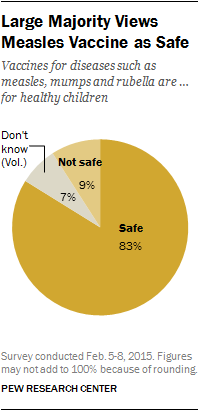Give some essential details in this illustration. The difference in the value of the smallest two segments of the graph is 2. The largest segment of the graph is predominantly a shade of dark yellow. 